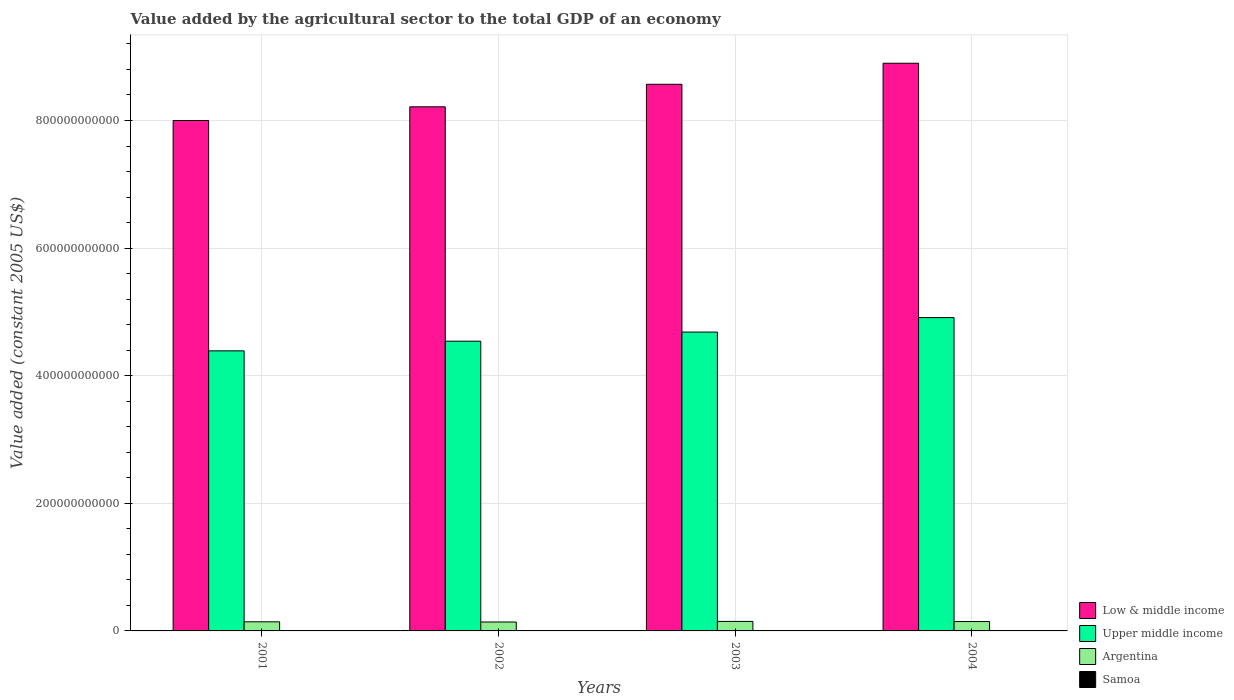Are the number of bars per tick equal to the number of legend labels?
Make the answer very short. Yes. Are the number of bars on each tick of the X-axis equal?
Your answer should be compact. Yes. How many bars are there on the 1st tick from the left?
Offer a terse response. 4. How many bars are there on the 4th tick from the right?
Offer a very short reply. 4. What is the label of the 1st group of bars from the left?
Provide a short and direct response. 2001. In how many cases, is the number of bars for a given year not equal to the number of legend labels?
Your response must be concise. 0. What is the value added by the agricultural sector in Argentina in 2001?
Your answer should be very brief. 1.43e+1. Across all years, what is the maximum value added by the agricultural sector in Samoa?
Provide a short and direct response. 6.30e+07. Across all years, what is the minimum value added by the agricultural sector in Argentina?
Provide a short and direct response. 1.40e+1. In which year was the value added by the agricultural sector in Argentina maximum?
Give a very brief answer. 2003. What is the total value added by the agricultural sector in Samoa in the graph?
Your answer should be very brief. 2.41e+08. What is the difference between the value added by the agricultural sector in Upper middle income in 2001 and that in 2003?
Keep it short and to the point. -2.95e+1. What is the difference between the value added by the agricultural sector in Argentina in 2002 and the value added by the agricultural sector in Samoa in 2004?
Ensure brevity in your answer.  1.39e+1. What is the average value added by the agricultural sector in Upper middle income per year?
Your answer should be very brief. 4.63e+11. In the year 2004, what is the difference between the value added by the agricultural sector in Low & middle income and value added by the agricultural sector in Argentina?
Ensure brevity in your answer.  8.75e+11. In how many years, is the value added by the agricultural sector in Upper middle income greater than 760000000000 US$?
Provide a succinct answer. 0. What is the ratio of the value added by the agricultural sector in Upper middle income in 2003 to that in 2004?
Provide a succinct answer. 0.95. Is the value added by the agricultural sector in Low & middle income in 2001 less than that in 2004?
Offer a terse response. Yes. Is the difference between the value added by the agricultural sector in Low & middle income in 2001 and 2004 greater than the difference between the value added by the agricultural sector in Argentina in 2001 and 2004?
Your answer should be compact. No. What is the difference between the highest and the second highest value added by the agricultural sector in Samoa?
Ensure brevity in your answer.  6.58e+04. What is the difference between the highest and the lowest value added by the agricultural sector in Upper middle income?
Offer a terse response. 5.22e+1. In how many years, is the value added by the agricultural sector in Low & middle income greater than the average value added by the agricultural sector in Low & middle income taken over all years?
Your answer should be very brief. 2. Is the sum of the value added by the agricultural sector in Low & middle income in 2002 and 2004 greater than the maximum value added by the agricultural sector in Upper middle income across all years?
Ensure brevity in your answer.  Yes. Is it the case that in every year, the sum of the value added by the agricultural sector in Low & middle income and value added by the agricultural sector in Argentina is greater than the sum of value added by the agricultural sector in Samoa and value added by the agricultural sector in Upper middle income?
Your response must be concise. Yes. What does the 2nd bar from the right in 2002 represents?
Your response must be concise. Argentina. Is it the case that in every year, the sum of the value added by the agricultural sector in Argentina and value added by the agricultural sector in Samoa is greater than the value added by the agricultural sector in Upper middle income?
Offer a terse response. No. What is the difference between two consecutive major ticks on the Y-axis?
Provide a short and direct response. 2.00e+11. Are the values on the major ticks of Y-axis written in scientific E-notation?
Provide a short and direct response. No. Does the graph contain any zero values?
Provide a short and direct response. No. Does the graph contain grids?
Offer a terse response. Yes. Where does the legend appear in the graph?
Provide a succinct answer. Bottom right. How many legend labels are there?
Provide a succinct answer. 4. How are the legend labels stacked?
Ensure brevity in your answer.  Vertical. What is the title of the graph?
Your answer should be compact. Value added by the agricultural sector to the total GDP of an economy. What is the label or title of the X-axis?
Keep it short and to the point. Years. What is the label or title of the Y-axis?
Your answer should be compact. Value added (constant 2005 US$). What is the Value added (constant 2005 US$) in Low & middle income in 2001?
Offer a very short reply. 8.00e+11. What is the Value added (constant 2005 US$) of Upper middle income in 2001?
Offer a very short reply. 4.39e+11. What is the Value added (constant 2005 US$) in Argentina in 2001?
Keep it short and to the point. 1.43e+1. What is the Value added (constant 2005 US$) in Samoa in 2001?
Provide a short and direct response. 6.30e+07. What is the Value added (constant 2005 US$) of Low & middle income in 2002?
Make the answer very short. 8.21e+11. What is the Value added (constant 2005 US$) of Upper middle income in 2002?
Keep it short and to the point. 4.54e+11. What is the Value added (constant 2005 US$) in Argentina in 2002?
Your answer should be compact. 1.40e+1. What is the Value added (constant 2005 US$) in Samoa in 2002?
Keep it short and to the point. 6.29e+07. What is the Value added (constant 2005 US$) of Low & middle income in 2003?
Provide a short and direct response. 8.57e+11. What is the Value added (constant 2005 US$) of Upper middle income in 2003?
Give a very brief answer. 4.68e+11. What is the Value added (constant 2005 US$) of Argentina in 2003?
Give a very brief answer. 1.49e+1. What is the Value added (constant 2005 US$) of Samoa in 2003?
Keep it short and to the point. 5.89e+07. What is the Value added (constant 2005 US$) in Low & middle income in 2004?
Offer a terse response. 8.90e+11. What is the Value added (constant 2005 US$) of Upper middle income in 2004?
Provide a short and direct response. 4.91e+11. What is the Value added (constant 2005 US$) of Argentina in 2004?
Your answer should be compact. 1.47e+1. What is the Value added (constant 2005 US$) of Samoa in 2004?
Your answer should be very brief. 5.60e+07. Across all years, what is the maximum Value added (constant 2005 US$) of Low & middle income?
Provide a short and direct response. 8.90e+11. Across all years, what is the maximum Value added (constant 2005 US$) of Upper middle income?
Provide a succinct answer. 4.91e+11. Across all years, what is the maximum Value added (constant 2005 US$) of Argentina?
Your answer should be compact. 1.49e+1. Across all years, what is the maximum Value added (constant 2005 US$) of Samoa?
Keep it short and to the point. 6.30e+07. Across all years, what is the minimum Value added (constant 2005 US$) of Low & middle income?
Give a very brief answer. 8.00e+11. Across all years, what is the minimum Value added (constant 2005 US$) in Upper middle income?
Give a very brief answer. 4.39e+11. Across all years, what is the minimum Value added (constant 2005 US$) of Argentina?
Make the answer very short. 1.40e+1. Across all years, what is the minimum Value added (constant 2005 US$) in Samoa?
Your answer should be compact. 5.60e+07. What is the total Value added (constant 2005 US$) of Low & middle income in the graph?
Your answer should be compact. 3.37e+12. What is the total Value added (constant 2005 US$) of Upper middle income in the graph?
Provide a short and direct response. 1.85e+12. What is the total Value added (constant 2005 US$) in Argentina in the graph?
Make the answer very short. 5.79e+1. What is the total Value added (constant 2005 US$) of Samoa in the graph?
Ensure brevity in your answer.  2.41e+08. What is the difference between the Value added (constant 2005 US$) of Low & middle income in 2001 and that in 2002?
Offer a terse response. -2.15e+1. What is the difference between the Value added (constant 2005 US$) of Upper middle income in 2001 and that in 2002?
Give a very brief answer. -1.52e+1. What is the difference between the Value added (constant 2005 US$) in Argentina in 2001 and that in 2002?
Give a very brief answer. 3.27e+08. What is the difference between the Value added (constant 2005 US$) of Samoa in 2001 and that in 2002?
Give a very brief answer. 6.58e+04. What is the difference between the Value added (constant 2005 US$) in Low & middle income in 2001 and that in 2003?
Your response must be concise. -5.68e+1. What is the difference between the Value added (constant 2005 US$) in Upper middle income in 2001 and that in 2003?
Ensure brevity in your answer.  -2.95e+1. What is the difference between the Value added (constant 2005 US$) in Argentina in 2001 and that in 2003?
Offer a very short reply. -6.33e+08. What is the difference between the Value added (constant 2005 US$) in Samoa in 2001 and that in 2003?
Your answer should be very brief. 4.07e+06. What is the difference between the Value added (constant 2005 US$) in Low & middle income in 2001 and that in 2004?
Provide a succinct answer. -8.97e+1. What is the difference between the Value added (constant 2005 US$) of Upper middle income in 2001 and that in 2004?
Provide a short and direct response. -5.22e+1. What is the difference between the Value added (constant 2005 US$) in Argentina in 2001 and that in 2004?
Offer a very short reply. -4.05e+08. What is the difference between the Value added (constant 2005 US$) in Samoa in 2001 and that in 2004?
Your response must be concise. 7.04e+06. What is the difference between the Value added (constant 2005 US$) in Low & middle income in 2002 and that in 2003?
Your answer should be very brief. -3.53e+1. What is the difference between the Value added (constant 2005 US$) in Upper middle income in 2002 and that in 2003?
Make the answer very short. -1.43e+1. What is the difference between the Value added (constant 2005 US$) in Argentina in 2002 and that in 2003?
Ensure brevity in your answer.  -9.60e+08. What is the difference between the Value added (constant 2005 US$) of Samoa in 2002 and that in 2003?
Your answer should be very brief. 4.00e+06. What is the difference between the Value added (constant 2005 US$) of Low & middle income in 2002 and that in 2004?
Offer a very short reply. -6.83e+1. What is the difference between the Value added (constant 2005 US$) of Upper middle income in 2002 and that in 2004?
Offer a terse response. -3.70e+1. What is the difference between the Value added (constant 2005 US$) in Argentina in 2002 and that in 2004?
Make the answer very short. -7.32e+08. What is the difference between the Value added (constant 2005 US$) of Samoa in 2002 and that in 2004?
Keep it short and to the point. 6.97e+06. What is the difference between the Value added (constant 2005 US$) of Low & middle income in 2003 and that in 2004?
Give a very brief answer. -3.30e+1. What is the difference between the Value added (constant 2005 US$) in Upper middle income in 2003 and that in 2004?
Offer a very short reply. -2.27e+1. What is the difference between the Value added (constant 2005 US$) of Argentina in 2003 and that in 2004?
Ensure brevity in your answer.  2.28e+08. What is the difference between the Value added (constant 2005 US$) in Samoa in 2003 and that in 2004?
Provide a succinct answer. 2.97e+06. What is the difference between the Value added (constant 2005 US$) of Low & middle income in 2001 and the Value added (constant 2005 US$) of Upper middle income in 2002?
Provide a succinct answer. 3.46e+11. What is the difference between the Value added (constant 2005 US$) of Low & middle income in 2001 and the Value added (constant 2005 US$) of Argentina in 2002?
Provide a short and direct response. 7.86e+11. What is the difference between the Value added (constant 2005 US$) in Low & middle income in 2001 and the Value added (constant 2005 US$) in Samoa in 2002?
Offer a terse response. 8.00e+11. What is the difference between the Value added (constant 2005 US$) of Upper middle income in 2001 and the Value added (constant 2005 US$) of Argentina in 2002?
Offer a terse response. 4.25e+11. What is the difference between the Value added (constant 2005 US$) in Upper middle income in 2001 and the Value added (constant 2005 US$) in Samoa in 2002?
Your answer should be compact. 4.39e+11. What is the difference between the Value added (constant 2005 US$) in Argentina in 2001 and the Value added (constant 2005 US$) in Samoa in 2002?
Keep it short and to the point. 1.42e+1. What is the difference between the Value added (constant 2005 US$) of Low & middle income in 2001 and the Value added (constant 2005 US$) of Upper middle income in 2003?
Your response must be concise. 3.32e+11. What is the difference between the Value added (constant 2005 US$) of Low & middle income in 2001 and the Value added (constant 2005 US$) of Argentina in 2003?
Keep it short and to the point. 7.85e+11. What is the difference between the Value added (constant 2005 US$) of Low & middle income in 2001 and the Value added (constant 2005 US$) of Samoa in 2003?
Give a very brief answer. 8.00e+11. What is the difference between the Value added (constant 2005 US$) in Upper middle income in 2001 and the Value added (constant 2005 US$) in Argentina in 2003?
Provide a succinct answer. 4.24e+11. What is the difference between the Value added (constant 2005 US$) in Upper middle income in 2001 and the Value added (constant 2005 US$) in Samoa in 2003?
Make the answer very short. 4.39e+11. What is the difference between the Value added (constant 2005 US$) of Argentina in 2001 and the Value added (constant 2005 US$) of Samoa in 2003?
Keep it short and to the point. 1.42e+1. What is the difference between the Value added (constant 2005 US$) of Low & middle income in 2001 and the Value added (constant 2005 US$) of Upper middle income in 2004?
Make the answer very short. 3.09e+11. What is the difference between the Value added (constant 2005 US$) of Low & middle income in 2001 and the Value added (constant 2005 US$) of Argentina in 2004?
Keep it short and to the point. 7.85e+11. What is the difference between the Value added (constant 2005 US$) of Low & middle income in 2001 and the Value added (constant 2005 US$) of Samoa in 2004?
Give a very brief answer. 8.00e+11. What is the difference between the Value added (constant 2005 US$) of Upper middle income in 2001 and the Value added (constant 2005 US$) of Argentina in 2004?
Give a very brief answer. 4.24e+11. What is the difference between the Value added (constant 2005 US$) of Upper middle income in 2001 and the Value added (constant 2005 US$) of Samoa in 2004?
Make the answer very short. 4.39e+11. What is the difference between the Value added (constant 2005 US$) in Argentina in 2001 and the Value added (constant 2005 US$) in Samoa in 2004?
Ensure brevity in your answer.  1.42e+1. What is the difference between the Value added (constant 2005 US$) of Low & middle income in 2002 and the Value added (constant 2005 US$) of Upper middle income in 2003?
Your answer should be very brief. 3.53e+11. What is the difference between the Value added (constant 2005 US$) of Low & middle income in 2002 and the Value added (constant 2005 US$) of Argentina in 2003?
Your response must be concise. 8.07e+11. What is the difference between the Value added (constant 2005 US$) of Low & middle income in 2002 and the Value added (constant 2005 US$) of Samoa in 2003?
Make the answer very short. 8.21e+11. What is the difference between the Value added (constant 2005 US$) of Upper middle income in 2002 and the Value added (constant 2005 US$) of Argentina in 2003?
Ensure brevity in your answer.  4.39e+11. What is the difference between the Value added (constant 2005 US$) of Upper middle income in 2002 and the Value added (constant 2005 US$) of Samoa in 2003?
Ensure brevity in your answer.  4.54e+11. What is the difference between the Value added (constant 2005 US$) in Argentina in 2002 and the Value added (constant 2005 US$) in Samoa in 2003?
Keep it short and to the point. 1.39e+1. What is the difference between the Value added (constant 2005 US$) of Low & middle income in 2002 and the Value added (constant 2005 US$) of Upper middle income in 2004?
Offer a terse response. 3.30e+11. What is the difference between the Value added (constant 2005 US$) in Low & middle income in 2002 and the Value added (constant 2005 US$) in Argentina in 2004?
Your answer should be compact. 8.07e+11. What is the difference between the Value added (constant 2005 US$) in Low & middle income in 2002 and the Value added (constant 2005 US$) in Samoa in 2004?
Your answer should be very brief. 8.21e+11. What is the difference between the Value added (constant 2005 US$) of Upper middle income in 2002 and the Value added (constant 2005 US$) of Argentina in 2004?
Provide a short and direct response. 4.39e+11. What is the difference between the Value added (constant 2005 US$) in Upper middle income in 2002 and the Value added (constant 2005 US$) in Samoa in 2004?
Your answer should be compact. 4.54e+11. What is the difference between the Value added (constant 2005 US$) of Argentina in 2002 and the Value added (constant 2005 US$) of Samoa in 2004?
Your response must be concise. 1.39e+1. What is the difference between the Value added (constant 2005 US$) of Low & middle income in 2003 and the Value added (constant 2005 US$) of Upper middle income in 2004?
Give a very brief answer. 3.66e+11. What is the difference between the Value added (constant 2005 US$) of Low & middle income in 2003 and the Value added (constant 2005 US$) of Argentina in 2004?
Make the answer very short. 8.42e+11. What is the difference between the Value added (constant 2005 US$) in Low & middle income in 2003 and the Value added (constant 2005 US$) in Samoa in 2004?
Make the answer very short. 8.57e+11. What is the difference between the Value added (constant 2005 US$) in Upper middle income in 2003 and the Value added (constant 2005 US$) in Argentina in 2004?
Your response must be concise. 4.54e+11. What is the difference between the Value added (constant 2005 US$) of Upper middle income in 2003 and the Value added (constant 2005 US$) of Samoa in 2004?
Offer a terse response. 4.68e+11. What is the difference between the Value added (constant 2005 US$) in Argentina in 2003 and the Value added (constant 2005 US$) in Samoa in 2004?
Make the answer very short. 1.49e+1. What is the average Value added (constant 2005 US$) of Low & middle income per year?
Provide a succinct answer. 8.42e+11. What is the average Value added (constant 2005 US$) of Upper middle income per year?
Your answer should be compact. 4.63e+11. What is the average Value added (constant 2005 US$) in Argentina per year?
Offer a terse response. 1.45e+1. What is the average Value added (constant 2005 US$) of Samoa per year?
Provide a short and direct response. 6.02e+07. In the year 2001, what is the difference between the Value added (constant 2005 US$) of Low & middle income and Value added (constant 2005 US$) of Upper middle income?
Offer a terse response. 3.61e+11. In the year 2001, what is the difference between the Value added (constant 2005 US$) of Low & middle income and Value added (constant 2005 US$) of Argentina?
Your answer should be very brief. 7.86e+11. In the year 2001, what is the difference between the Value added (constant 2005 US$) in Low & middle income and Value added (constant 2005 US$) in Samoa?
Provide a succinct answer. 8.00e+11. In the year 2001, what is the difference between the Value added (constant 2005 US$) of Upper middle income and Value added (constant 2005 US$) of Argentina?
Give a very brief answer. 4.25e+11. In the year 2001, what is the difference between the Value added (constant 2005 US$) of Upper middle income and Value added (constant 2005 US$) of Samoa?
Your answer should be compact. 4.39e+11. In the year 2001, what is the difference between the Value added (constant 2005 US$) of Argentina and Value added (constant 2005 US$) of Samoa?
Offer a very short reply. 1.42e+1. In the year 2002, what is the difference between the Value added (constant 2005 US$) of Low & middle income and Value added (constant 2005 US$) of Upper middle income?
Your response must be concise. 3.67e+11. In the year 2002, what is the difference between the Value added (constant 2005 US$) of Low & middle income and Value added (constant 2005 US$) of Argentina?
Offer a terse response. 8.07e+11. In the year 2002, what is the difference between the Value added (constant 2005 US$) in Low & middle income and Value added (constant 2005 US$) in Samoa?
Give a very brief answer. 8.21e+11. In the year 2002, what is the difference between the Value added (constant 2005 US$) in Upper middle income and Value added (constant 2005 US$) in Argentina?
Keep it short and to the point. 4.40e+11. In the year 2002, what is the difference between the Value added (constant 2005 US$) in Upper middle income and Value added (constant 2005 US$) in Samoa?
Offer a very short reply. 4.54e+11. In the year 2002, what is the difference between the Value added (constant 2005 US$) in Argentina and Value added (constant 2005 US$) in Samoa?
Your answer should be compact. 1.39e+1. In the year 2003, what is the difference between the Value added (constant 2005 US$) in Low & middle income and Value added (constant 2005 US$) in Upper middle income?
Your answer should be very brief. 3.88e+11. In the year 2003, what is the difference between the Value added (constant 2005 US$) in Low & middle income and Value added (constant 2005 US$) in Argentina?
Your answer should be compact. 8.42e+11. In the year 2003, what is the difference between the Value added (constant 2005 US$) in Low & middle income and Value added (constant 2005 US$) in Samoa?
Offer a terse response. 8.57e+11. In the year 2003, what is the difference between the Value added (constant 2005 US$) of Upper middle income and Value added (constant 2005 US$) of Argentina?
Offer a terse response. 4.53e+11. In the year 2003, what is the difference between the Value added (constant 2005 US$) in Upper middle income and Value added (constant 2005 US$) in Samoa?
Make the answer very short. 4.68e+11. In the year 2003, what is the difference between the Value added (constant 2005 US$) of Argentina and Value added (constant 2005 US$) of Samoa?
Your response must be concise. 1.49e+1. In the year 2004, what is the difference between the Value added (constant 2005 US$) of Low & middle income and Value added (constant 2005 US$) of Upper middle income?
Keep it short and to the point. 3.99e+11. In the year 2004, what is the difference between the Value added (constant 2005 US$) in Low & middle income and Value added (constant 2005 US$) in Argentina?
Give a very brief answer. 8.75e+11. In the year 2004, what is the difference between the Value added (constant 2005 US$) in Low & middle income and Value added (constant 2005 US$) in Samoa?
Your answer should be compact. 8.90e+11. In the year 2004, what is the difference between the Value added (constant 2005 US$) in Upper middle income and Value added (constant 2005 US$) in Argentina?
Offer a very short reply. 4.76e+11. In the year 2004, what is the difference between the Value added (constant 2005 US$) of Upper middle income and Value added (constant 2005 US$) of Samoa?
Provide a succinct answer. 4.91e+11. In the year 2004, what is the difference between the Value added (constant 2005 US$) of Argentina and Value added (constant 2005 US$) of Samoa?
Your answer should be compact. 1.46e+1. What is the ratio of the Value added (constant 2005 US$) of Low & middle income in 2001 to that in 2002?
Give a very brief answer. 0.97. What is the ratio of the Value added (constant 2005 US$) of Upper middle income in 2001 to that in 2002?
Offer a terse response. 0.97. What is the ratio of the Value added (constant 2005 US$) of Argentina in 2001 to that in 2002?
Your response must be concise. 1.02. What is the ratio of the Value added (constant 2005 US$) in Samoa in 2001 to that in 2002?
Provide a short and direct response. 1. What is the ratio of the Value added (constant 2005 US$) of Low & middle income in 2001 to that in 2003?
Offer a terse response. 0.93. What is the ratio of the Value added (constant 2005 US$) of Upper middle income in 2001 to that in 2003?
Your answer should be very brief. 0.94. What is the ratio of the Value added (constant 2005 US$) in Argentina in 2001 to that in 2003?
Ensure brevity in your answer.  0.96. What is the ratio of the Value added (constant 2005 US$) in Samoa in 2001 to that in 2003?
Your answer should be compact. 1.07. What is the ratio of the Value added (constant 2005 US$) in Low & middle income in 2001 to that in 2004?
Your answer should be compact. 0.9. What is the ratio of the Value added (constant 2005 US$) of Upper middle income in 2001 to that in 2004?
Make the answer very short. 0.89. What is the ratio of the Value added (constant 2005 US$) in Argentina in 2001 to that in 2004?
Keep it short and to the point. 0.97. What is the ratio of the Value added (constant 2005 US$) in Samoa in 2001 to that in 2004?
Your response must be concise. 1.13. What is the ratio of the Value added (constant 2005 US$) in Low & middle income in 2002 to that in 2003?
Make the answer very short. 0.96. What is the ratio of the Value added (constant 2005 US$) of Upper middle income in 2002 to that in 2003?
Your answer should be compact. 0.97. What is the ratio of the Value added (constant 2005 US$) of Argentina in 2002 to that in 2003?
Your answer should be very brief. 0.94. What is the ratio of the Value added (constant 2005 US$) of Samoa in 2002 to that in 2003?
Keep it short and to the point. 1.07. What is the ratio of the Value added (constant 2005 US$) in Low & middle income in 2002 to that in 2004?
Your answer should be very brief. 0.92. What is the ratio of the Value added (constant 2005 US$) in Upper middle income in 2002 to that in 2004?
Your answer should be compact. 0.92. What is the ratio of the Value added (constant 2005 US$) of Argentina in 2002 to that in 2004?
Provide a short and direct response. 0.95. What is the ratio of the Value added (constant 2005 US$) of Samoa in 2002 to that in 2004?
Make the answer very short. 1.12. What is the ratio of the Value added (constant 2005 US$) in Low & middle income in 2003 to that in 2004?
Offer a very short reply. 0.96. What is the ratio of the Value added (constant 2005 US$) of Upper middle income in 2003 to that in 2004?
Offer a very short reply. 0.95. What is the ratio of the Value added (constant 2005 US$) of Argentina in 2003 to that in 2004?
Your answer should be compact. 1.02. What is the ratio of the Value added (constant 2005 US$) in Samoa in 2003 to that in 2004?
Your response must be concise. 1.05. What is the difference between the highest and the second highest Value added (constant 2005 US$) in Low & middle income?
Give a very brief answer. 3.30e+1. What is the difference between the highest and the second highest Value added (constant 2005 US$) of Upper middle income?
Your answer should be very brief. 2.27e+1. What is the difference between the highest and the second highest Value added (constant 2005 US$) in Argentina?
Offer a terse response. 2.28e+08. What is the difference between the highest and the second highest Value added (constant 2005 US$) of Samoa?
Make the answer very short. 6.58e+04. What is the difference between the highest and the lowest Value added (constant 2005 US$) of Low & middle income?
Offer a very short reply. 8.97e+1. What is the difference between the highest and the lowest Value added (constant 2005 US$) in Upper middle income?
Offer a very short reply. 5.22e+1. What is the difference between the highest and the lowest Value added (constant 2005 US$) of Argentina?
Ensure brevity in your answer.  9.60e+08. What is the difference between the highest and the lowest Value added (constant 2005 US$) of Samoa?
Ensure brevity in your answer.  7.04e+06. 